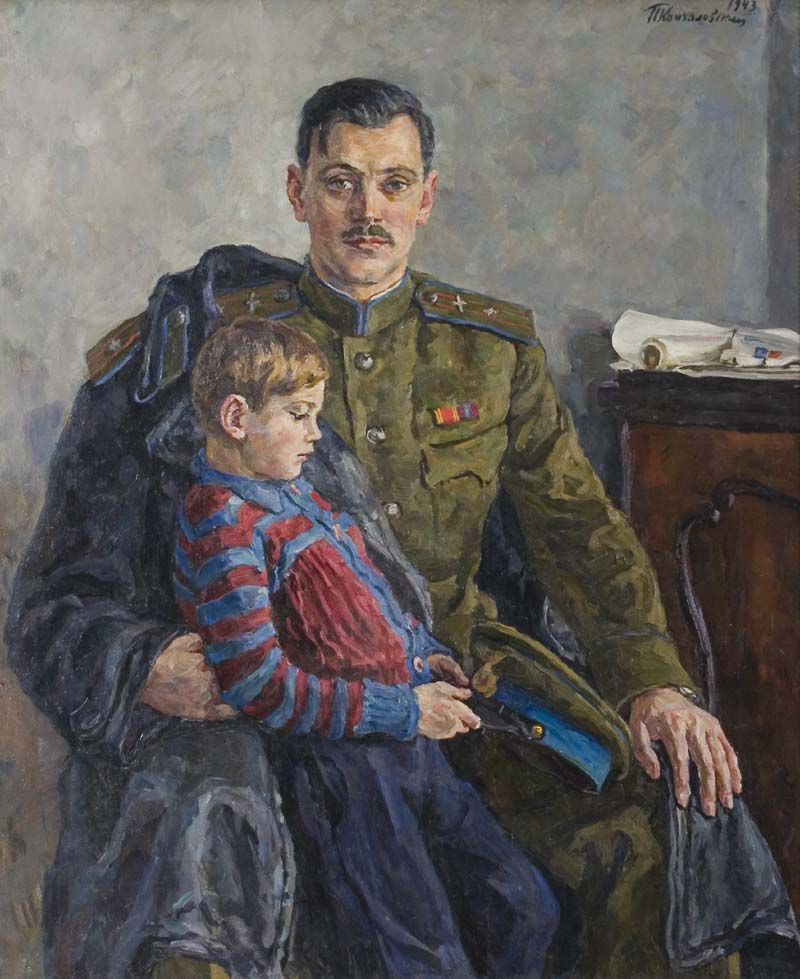What is this photo about? The image is a captivating oil painting rendered in the impressionist style, characterized by its loose brushstrokes and muted color palette. At the center, there is a man in a military uniform, seated with a young boy on his lap. The man's uniform is green with a distinctive red stripe on the collar and a medal on his chest, indicating his military rank and achievements. The young boy, presumably his son, is dressed in a red and blue striped shirt, standing out vibrantly against the scene's softer hues. The background is a simple gray wall with a desk and a white cloth visible, providing depth and context to the setting. The painting is signed 'Theo van Rysselberghe 1913' in the lower right corner, revealing the artist and the year it was created. This composition suggests a tender, intimate moment of familial bonding amidst the challenges of military life. 